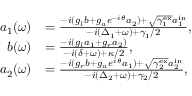<formula> <loc_0><loc_0><loc_500><loc_500>\begin{array} { r l } { a _ { 1 } ( \omega ) } & { = \frac { - i ( g _ { l } b + g _ { a } e ^ { - i \theta } a _ { 2 } ) + \sqrt { \gamma _ { 1 } ^ { e x } } a _ { 1 } ^ { i n } } { - i ( \Delta _ { 1 } + \omega ) + \gamma _ { 1 } / 2 } , } \\ { b ( \omega ) } & { = \frac { - i ( g _ { l } a _ { 1 } + g _ { r } a _ { 2 } ) } { - i ( \delta + \omega ) + \kappa / 2 } , } \\ { a _ { 2 } ( \omega ) } & { = \frac { - i ( g _ { r } b + g _ { a } e ^ { i \theta } a _ { 1 } ) + \sqrt { \gamma _ { 2 } ^ { e x } } a _ { 2 } ^ { i n } } { - i ( \Delta _ { 2 } + \omega ) + \gamma _ { 2 } / 2 } , } \end{array}</formula> 